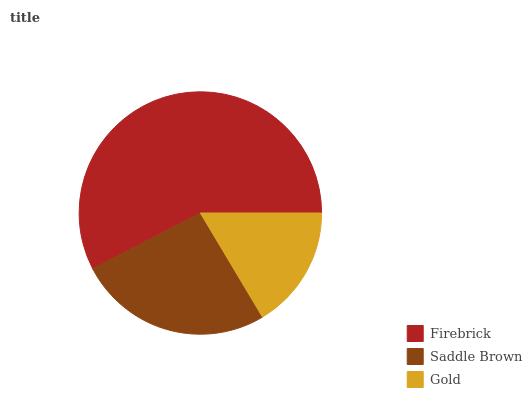Is Gold the minimum?
Answer yes or no. Yes. Is Firebrick the maximum?
Answer yes or no. Yes. Is Saddle Brown the minimum?
Answer yes or no. No. Is Saddle Brown the maximum?
Answer yes or no. No. Is Firebrick greater than Saddle Brown?
Answer yes or no. Yes. Is Saddle Brown less than Firebrick?
Answer yes or no. Yes. Is Saddle Brown greater than Firebrick?
Answer yes or no. No. Is Firebrick less than Saddle Brown?
Answer yes or no. No. Is Saddle Brown the high median?
Answer yes or no. Yes. Is Saddle Brown the low median?
Answer yes or no. Yes. Is Firebrick the high median?
Answer yes or no. No. Is Gold the low median?
Answer yes or no. No. 